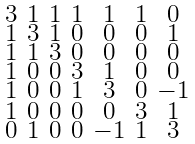Convert formula to latex. <formula><loc_0><loc_0><loc_500><loc_500>\begin{smallmatrix} 3 & 1 & 1 & 1 & 1 & 1 & 0 \\ 1 & 3 & 1 & 0 & 0 & 0 & 1 \\ 1 & 1 & 3 & 0 & 0 & 0 & 0 \\ 1 & 0 & 0 & 3 & 1 & 0 & 0 \\ 1 & 0 & 0 & 1 & 3 & 0 & - 1 \\ 1 & 0 & 0 & 0 & 0 & 3 & 1 \\ 0 & 1 & 0 & 0 & - 1 & 1 & 3 \end{smallmatrix}</formula> 